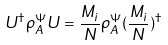Convert formula to latex. <formula><loc_0><loc_0><loc_500><loc_500>U ^ { \dagger } \rho _ { A } ^ { \Psi } U = \frac { M _ { i } } { N } \rho _ { A } ^ { \Psi } ( \frac { M _ { i } } { N } ) ^ { \dagger }</formula> 